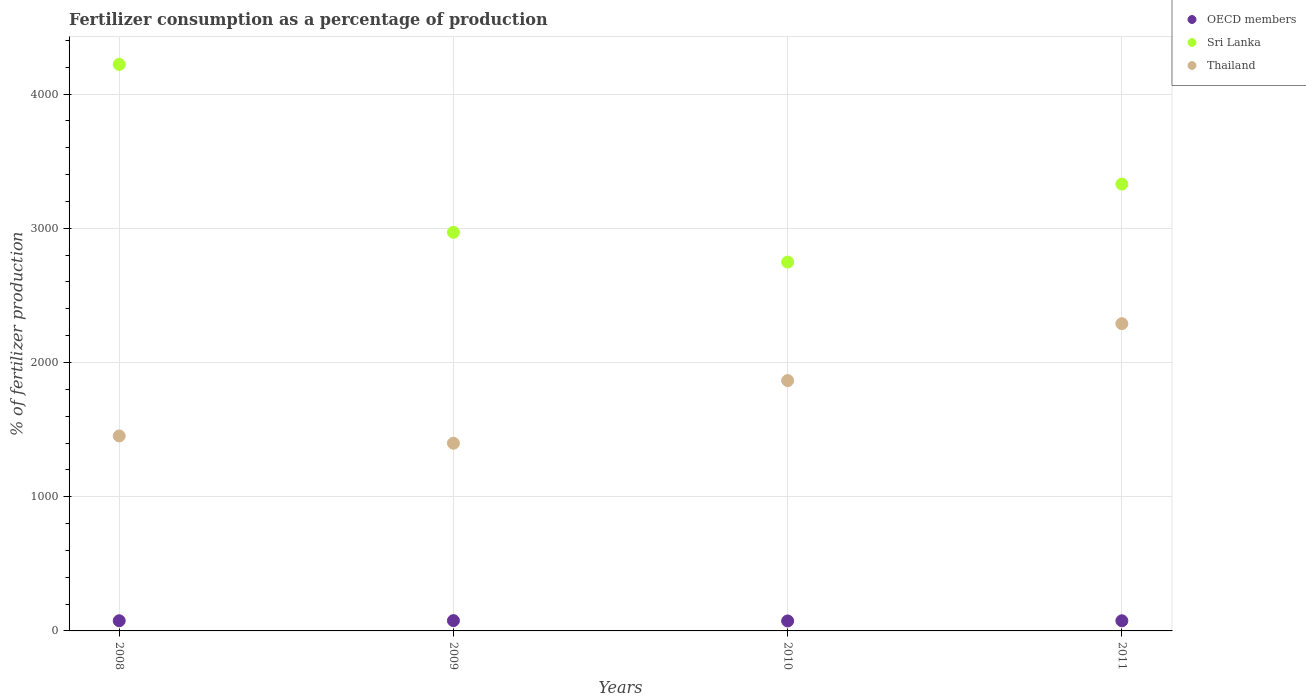How many different coloured dotlines are there?
Offer a terse response. 3. What is the percentage of fertilizers consumed in Sri Lanka in 2009?
Ensure brevity in your answer.  2970.1. Across all years, what is the maximum percentage of fertilizers consumed in OECD members?
Provide a succinct answer. 76.72. Across all years, what is the minimum percentage of fertilizers consumed in Thailand?
Offer a very short reply. 1398.34. In which year was the percentage of fertilizers consumed in Thailand maximum?
Your answer should be very brief. 2011. What is the total percentage of fertilizers consumed in OECD members in the graph?
Your answer should be very brief. 302.44. What is the difference between the percentage of fertilizers consumed in Sri Lanka in 2008 and that in 2010?
Your response must be concise. 1472.78. What is the difference between the percentage of fertilizers consumed in Thailand in 2008 and the percentage of fertilizers consumed in Sri Lanka in 2010?
Your answer should be compact. -1295.73. What is the average percentage of fertilizers consumed in Thailand per year?
Your response must be concise. 1751.51. In the year 2009, what is the difference between the percentage of fertilizers consumed in Sri Lanka and percentage of fertilizers consumed in Thailand?
Make the answer very short. 1571.76. What is the ratio of the percentage of fertilizers consumed in OECD members in 2008 to that in 2010?
Your answer should be very brief. 1.02. Is the difference between the percentage of fertilizers consumed in Sri Lanka in 2008 and 2011 greater than the difference between the percentage of fertilizers consumed in Thailand in 2008 and 2011?
Your response must be concise. Yes. What is the difference between the highest and the second highest percentage of fertilizers consumed in Thailand?
Offer a very short reply. 424.11. What is the difference between the highest and the lowest percentage of fertilizers consumed in Thailand?
Your answer should be very brief. 891.16. Is the sum of the percentage of fertilizers consumed in Sri Lanka in 2010 and 2011 greater than the maximum percentage of fertilizers consumed in OECD members across all years?
Provide a short and direct response. Yes. Is the percentage of fertilizers consumed in OECD members strictly less than the percentage of fertilizers consumed in Sri Lanka over the years?
Your answer should be compact. Yes. How many dotlines are there?
Offer a very short reply. 3. How many years are there in the graph?
Your answer should be very brief. 4. Are the values on the major ticks of Y-axis written in scientific E-notation?
Give a very brief answer. No. Does the graph contain any zero values?
Offer a very short reply. No. Where does the legend appear in the graph?
Offer a terse response. Top right. What is the title of the graph?
Make the answer very short. Fertilizer consumption as a percentage of production. What is the label or title of the Y-axis?
Keep it short and to the point. % of fertilizer production. What is the % of fertilizer production in OECD members in 2008?
Provide a short and direct response. 75.84. What is the % of fertilizer production of Sri Lanka in 2008?
Provide a succinct answer. 4221.35. What is the % of fertilizer production of Thailand in 2008?
Offer a very short reply. 1452.84. What is the % of fertilizer production of OECD members in 2009?
Keep it short and to the point. 76.72. What is the % of fertilizer production of Sri Lanka in 2009?
Offer a terse response. 2970.1. What is the % of fertilizer production of Thailand in 2009?
Your response must be concise. 1398.34. What is the % of fertilizer production in OECD members in 2010?
Provide a short and direct response. 74.26. What is the % of fertilizer production in Sri Lanka in 2010?
Provide a short and direct response. 2748.57. What is the % of fertilizer production in Thailand in 2010?
Your response must be concise. 1865.38. What is the % of fertilizer production in OECD members in 2011?
Keep it short and to the point. 75.62. What is the % of fertilizer production of Sri Lanka in 2011?
Provide a short and direct response. 3329.6. What is the % of fertilizer production in Thailand in 2011?
Ensure brevity in your answer.  2289.49. Across all years, what is the maximum % of fertilizer production of OECD members?
Give a very brief answer. 76.72. Across all years, what is the maximum % of fertilizer production of Sri Lanka?
Offer a terse response. 4221.35. Across all years, what is the maximum % of fertilizer production of Thailand?
Offer a terse response. 2289.49. Across all years, what is the minimum % of fertilizer production of OECD members?
Your answer should be compact. 74.26. Across all years, what is the minimum % of fertilizer production in Sri Lanka?
Keep it short and to the point. 2748.57. Across all years, what is the minimum % of fertilizer production of Thailand?
Provide a short and direct response. 1398.34. What is the total % of fertilizer production of OECD members in the graph?
Your answer should be compact. 302.44. What is the total % of fertilizer production in Sri Lanka in the graph?
Your response must be concise. 1.33e+04. What is the total % of fertilizer production of Thailand in the graph?
Provide a short and direct response. 7006.05. What is the difference between the % of fertilizer production in OECD members in 2008 and that in 2009?
Your response must be concise. -0.87. What is the difference between the % of fertilizer production of Sri Lanka in 2008 and that in 2009?
Offer a very short reply. 1251.25. What is the difference between the % of fertilizer production of Thailand in 2008 and that in 2009?
Provide a short and direct response. 54.51. What is the difference between the % of fertilizer production of OECD members in 2008 and that in 2010?
Your response must be concise. 1.58. What is the difference between the % of fertilizer production of Sri Lanka in 2008 and that in 2010?
Provide a succinct answer. 1472.78. What is the difference between the % of fertilizer production in Thailand in 2008 and that in 2010?
Provide a succinct answer. -412.54. What is the difference between the % of fertilizer production in OECD members in 2008 and that in 2011?
Your response must be concise. 0.22. What is the difference between the % of fertilizer production of Sri Lanka in 2008 and that in 2011?
Your response must be concise. 891.75. What is the difference between the % of fertilizer production in Thailand in 2008 and that in 2011?
Provide a short and direct response. -836.65. What is the difference between the % of fertilizer production in OECD members in 2009 and that in 2010?
Your answer should be compact. 2.45. What is the difference between the % of fertilizer production in Sri Lanka in 2009 and that in 2010?
Make the answer very short. 221.53. What is the difference between the % of fertilizer production of Thailand in 2009 and that in 2010?
Provide a succinct answer. -467.05. What is the difference between the % of fertilizer production in OECD members in 2009 and that in 2011?
Your response must be concise. 1.1. What is the difference between the % of fertilizer production in Sri Lanka in 2009 and that in 2011?
Your answer should be very brief. -359.5. What is the difference between the % of fertilizer production in Thailand in 2009 and that in 2011?
Ensure brevity in your answer.  -891.16. What is the difference between the % of fertilizer production in OECD members in 2010 and that in 2011?
Your answer should be very brief. -1.35. What is the difference between the % of fertilizer production of Sri Lanka in 2010 and that in 2011?
Offer a terse response. -581.03. What is the difference between the % of fertilizer production in Thailand in 2010 and that in 2011?
Your answer should be very brief. -424.11. What is the difference between the % of fertilizer production of OECD members in 2008 and the % of fertilizer production of Sri Lanka in 2009?
Offer a very short reply. -2894.26. What is the difference between the % of fertilizer production of OECD members in 2008 and the % of fertilizer production of Thailand in 2009?
Offer a terse response. -1322.49. What is the difference between the % of fertilizer production in Sri Lanka in 2008 and the % of fertilizer production in Thailand in 2009?
Your answer should be very brief. 2823.02. What is the difference between the % of fertilizer production of OECD members in 2008 and the % of fertilizer production of Sri Lanka in 2010?
Provide a short and direct response. -2672.73. What is the difference between the % of fertilizer production of OECD members in 2008 and the % of fertilizer production of Thailand in 2010?
Your response must be concise. -1789.54. What is the difference between the % of fertilizer production of Sri Lanka in 2008 and the % of fertilizer production of Thailand in 2010?
Your response must be concise. 2355.97. What is the difference between the % of fertilizer production in OECD members in 2008 and the % of fertilizer production in Sri Lanka in 2011?
Offer a terse response. -3253.76. What is the difference between the % of fertilizer production of OECD members in 2008 and the % of fertilizer production of Thailand in 2011?
Your answer should be compact. -2213.65. What is the difference between the % of fertilizer production in Sri Lanka in 2008 and the % of fertilizer production in Thailand in 2011?
Give a very brief answer. 1931.86. What is the difference between the % of fertilizer production in OECD members in 2009 and the % of fertilizer production in Sri Lanka in 2010?
Your answer should be compact. -2671.85. What is the difference between the % of fertilizer production in OECD members in 2009 and the % of fertilizer production in Thailand in 2010?
Your response must be concise. -1788.67. What is the difference between the % of fertilizer production of Sri Lanka in 2009 and the % of fertilizer production of Thailand in 2010?
Provide a succinct answer. 1104.72. What is the difference between the % of fertilizer production of OECD members in 2009 and the % of fertilizer production of Sri Lanka in 2011?
Keep it short and to the point. -3252.88. What is the difference between the % of fertilizer production in OECD members in 2009 and the % of fertilizer production in Thailand in 2011?
Provide a short and direct response. -2212.78. What is the difference between the % of fertilizer production in Sri Lanka in 2009 and the % of fertilizer production in Thailand in 2011?
Your answer should be compact. 680.61. What is the difference between the % of fertilizer production in OECD members in 2010 and the % of fertilizer production in Sri Lanka in 2011?
Keep it short and to the point. -3255.34. What is the difference between the % of fertilizer production in OECD members in 2010 and the % of fertilizer production in Thailand in 2011?
Provide a succinct answer. -2215.23. What is the difference between the % of fertilizer production in Sri Lanka in 2010 and the % of fertilizer production in Thailand in 2011?
Your answer should be compact. 459.08. What is the average % of fertilizer production of OECD members per year?
Your answer should be compact. 75.61. What is the average % of fertilizer production in Sri Lanka per year?
Give a very brief answer. 3317.41. What is the average % of fertilizer production of Thailand per year?
Your answer should be very brief. 1751.51. In the year 2008, what is the difference between the % of fertilizer production of OECD members and % of fertilizer production of Sri Lanka?
Offer a very short reply. -4145.51. In the year 2008, what is the difference between the % of fertilizer production of OECD members and % of fertilizer production of Thailand?
Offer a terse response. -1377. In the year 2008, what is the difference between the % of fertilizer production of Sri Lanka and % of fertilizer production of Thailand?
Offer a terse response. 2768.51. In the year 2009, what is the difference between the % of fertilizer production in OECD members and % of fertilizer production in Sri Lanka?
Your answer should be compact. -2893.38. In the year 2009, what is the difference between the % of fertilizer production in OECD members and % of fertilizer production in Thailand?
Your answer should be very brief. -1321.62. In the year 2009, what is the difference between the % of fertilizer production in Sri Lanka and % of fertilizer production in Thailand?
Ensure brevity in your answer.  1571.76. In the year 2010, what is the difference between the % of fertilizer production in OECD members and % of fertilizer production in Sri Lanka?
Your response must be concise. -2674.31. In the year 2010, what is the difference between the % of fertilizer production in OECD members and % of fertilizer production in Thailand?
Offer a very short reply. -1791.12. In the year 2010, what is the difference between the % of fertilizer production of Sri Lanka and % of fertilizer production of Thailand?
Provide a short and direct response. 883.19. In the year 2011, what is the difference between the % of fertilizer production of OECD members and % of fertilizer production of Sri Lanka?
Ensure brevity in your answer.  -3253.98. In the year 2011, what is the difference between the % of fertilizer production of OECD members and % of fertilizer production of Thailand?
Offer a terse response. -2213.88. In the year 2011, what is the difference between the % of fertilizer production of Sri Lanka and % of fertilizer production of Thailand?
Provide a succinct answer. 1040.11. What is the ratio of the % of fertilizer production of OECD members in 2008 to that in 2009?
Your answer should be very brief. 0.99. What is the ratio of the % of fertilizer production in Sri Lanka in 2008 to that in 2009?
Offer a very short reply. 1.42. What is the ratio of the % of fertilizer production of Thailand in 2008 to that in 2009?
Offer a very short reply. 1.04. What is the ratio of the % of fertilizer production in OECD members in 2008 to that in 2010?
Give a very brief answer. 1.02. What is the ratio of the % of fertilizer production of Sri Lanka in 2008 to that in 2010?
Your response must be concise. 1.54. What is the ratio of the % of fertilizer production of Thailand in 2008 to that in 2010?
Ensure brevity in your answer.  0.78. What is the ratio of the % of fertilizer production of Sri Lanka in 2008 to that in 2011?
Make the answer very short. 1.27. What is the ratio of the % of fertilizer production in Thailand in 2008 to that in 2011?
Provide a succinct answer. 0.63. What is the ratio of the % of fertilizer production of OECD members in 2009 to that in 2010?
Make the answer very short. 1.03. What is the ratio of the % of fertilizer production of Sri Lanka in 2009 to that in 2010?
Offer a very short reply. 1.08. What is the ratio of the % of fertilizer production of Thailand in 2009 to that in 2010?
Offer a terse response. 0.75. What is the ratio of the % of fertilizer production of OECD members in 2009 to that in 2011?
Your response must be concise. 1.01. What is the ratio of the % of fertilizer production of Sri Lanka in 2009 to that in 2011?
Your response must be concise. 0.89. What is the ratio of the % of fertilizer production in Thailand in 2009 to that in 2011?
Your response must be concise. 0.61. What is the ratio of the % of fertilizer production in OECD members in 2010 to that in 2011?
Make the answer very short. 0.98. What is the ratio of the % of fertilizer production of Sri Lanka in 2010 to that in 2011?
Keep it short and to the point. 0.83. What is the ratio of the % of fertilizer production in Thailand in 2010 to that in 2011?
Your answer should be compact. 0.81. What is the difference between the highest and the second highest % of fertilizer production in OECD members?
Provide a short and direct response. 0.87. What is the difference between the highest and the second highest % of fertilizer production of Sri Lanka?
Make the answer very short. 891.75. What is the difference between the highest and the second highest % of fertilizer production in Thailand?
Ensure brevity in your answer.  424.11. What is the difference between the highest and the lowest % of fertilizer production of OECD members?
Your response must be concise. 2.45. What is the difference between the highest and the lowest % of fertilizer production of Sri Lanka?
Provide a short and direct response. 1472.78. What is the difference between the highest and the lowest % of fertilizer production of Thailand?
Your response must be concise. 891.16. 